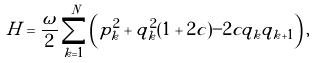<formula> <loc_0><loc_0><loc_500><loc_500>H = \frac { \omega } { 2 } \sum _ { k = 1 } ^ { N } \left ( p _ { k } ^ { 2 } + q _ { k } ^ { 2 } ( 1 + 2 c ) - 2 c q _ { k } q _ { k + 1 } \right ) ,</formula> 